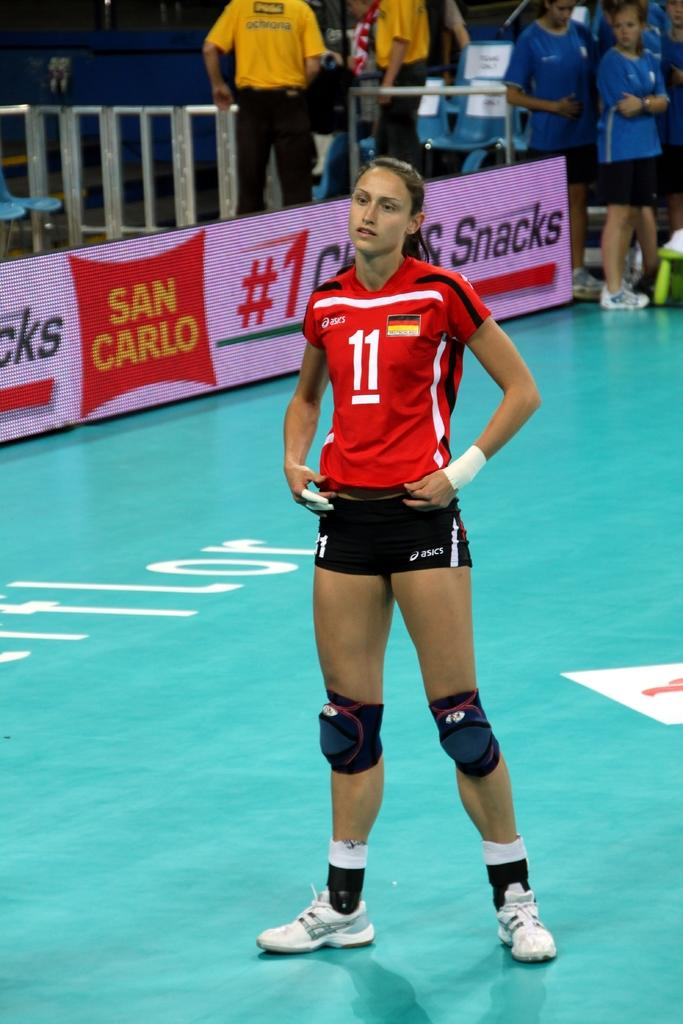Provide a one-sentence caption for the provided image. A girl in a uniform with the number 11 on it stands on a court with her hands at her hips. 